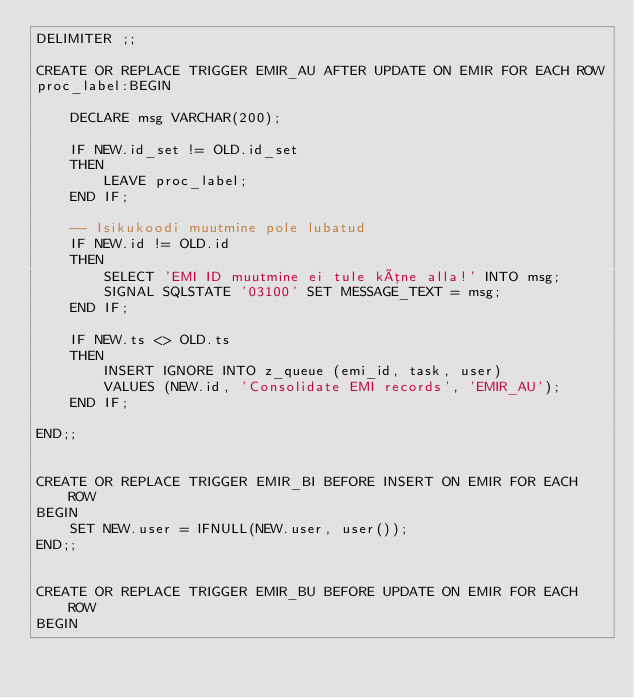Convert code to text. <code><loc_0><loc_0><loc_500><loc_500><_SQL_>DELIMITER ;;

CREATE OR REPLACE TRIGGER EMIR_AU AFTER UPDATE ON EMIR FOR EACH ROW
proc_label:BEGIN

    DECLARE msg VARCHAR(200);

    IF NEW.id_set != OLD.id_set
    THEN
        LEAVE proc_label;
    END IF;

    -- Isikukoodi muutmine pole lubatud
    IF NEW.id != OLD.id
    THEN
        SELECT 'EMI ID muutmine ei tule kõne alla!' INTO msg;
        SIGNAL SQLSTATE '03100' SET MESSAGE_TEXT = msg;
    END IF;

    IF NEW.ts <> OLD.ts
    THEN
        INSERT IGNORE INTO z_queue (emi_id, task, user)
        VALUES (NEW.id, 'Consolidate EMI records', 'EMIR_AU');
    END IF;

END;;


CREATE OR REPLACE TRIGGER EMIR_BI BEFORE INSERT ON EMIR FOR EACH ROW
BEGIN
    SET NEW.user = IFNULL(NEW.user, user());
END;;


CREATE OR REPLACE TRIGGER EMIR_BU BEFORE UPDATE ON EMIR FOR EACH ROW
BEGIN</code> 